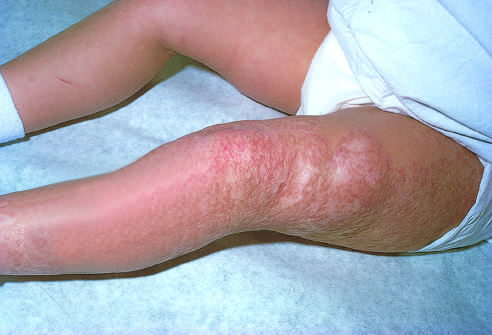what had the congenital capillary hemangioma at 2 years of age after the lesion undergone?
Answer the question using a single word or phrase. Spontaneous regression 